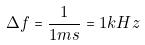<formula> <loc_0><loc_0><loc_500><loc_500>\Delta f = \frac { 1 } { 1 m s } = 1 k H z</formula> 